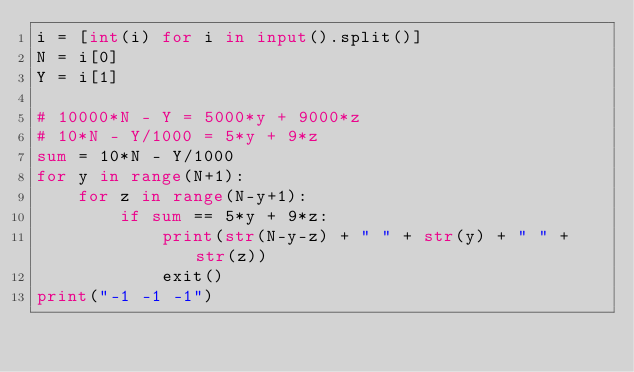Convert code to text. <code><loc_0><loc_0><loc_500><loc_500><_Python_>i = [int(i) for i in input().split()]
N = i[0]
Y = i[1]

# 10000*N - Y = 5000*y + 9000*z
# 10*N - Y/1000 = 5*y + 9*z
sum = 10*N - Y/1000
for y in range(N+1):
    for z in range(N-y+1):
        if sum == 5*y + 9*z:
            print(str(N-y-z) + " " + str(y) + " " + str(z))
            exit()
print("-1 -1 -1")</code> 